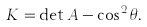Convert formula to latex. <formula><loc_0><loc_0><loc_500><loc_500>K = \det A - \cos ^ { 2 } \theta .</formula> 